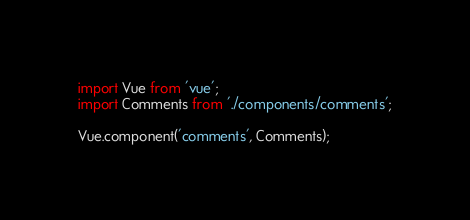<code> <loc_0><loc_0><loc_500><loc_500><_JavaScript_>import Vue from 'vue';
import Comments from './components/comments';

Vue.component('comments', Comments);
</code> 